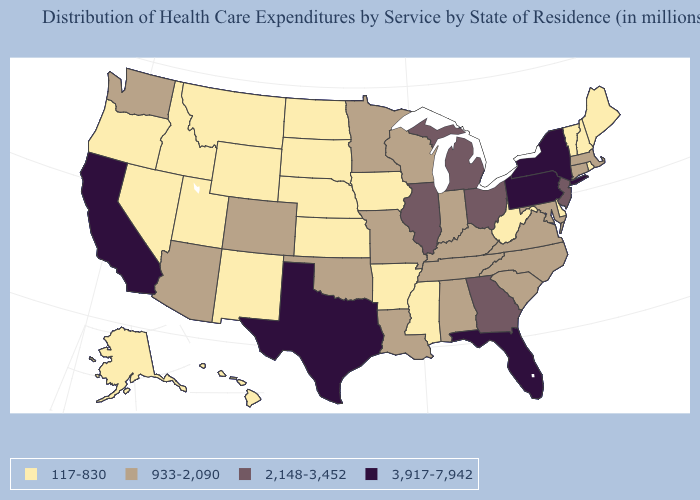What is the lowest value in the USA?
Answer briefly. 117-830. Which states have the lowest value in the USA?
Give a very brief answer. Alaska, Arkansas, Delaware, Hawaii, Idaho, Iowa, Kansas, Maine, Mississippi, Montana, Nebraska, Nevada, New Hampshire, New Mexico, North Dakota, Oregon, Rhode Island, South Dakota, Utah, Vermont, West Virginia, Wyoming. Does Maine have the lowest value in the Northeast?
Write a very short answer. Yes. What is the value of Kentucky?
Concise answer only. 933-2,090. What is the value of Alaska?
Give a very brief answer. 117-830. Among the states that border New Hampshire , which have the highest value?
Quick response, please. Massachusetts. What is the value of New Jersey?
Write a very short answer. 2,148-3,452. Which states have the highest value in the USA?
Quick response, please. California, Florida, New York, Pennsylvania, Texas. Does North Dakota have the lowest value in the USA?
Short answer required. Yes. Name the states that have a value in the range 2,148-3,452?
Concise answer only. Georgia, Illinois, Michigan, New Jersey, Ohio. Does the first symbol in the legend represent the smallest category?
Be succinct. Yes. What is the value of Pennsylvania?
Short answer required. 3,917-7,942. What is the value of Arizona?
Concise answer only. 933-2,090. Does New York have the lowest value in the USA?
Short answer required. No. What is the value of Alaska?
Concise answer only. 117-830. 